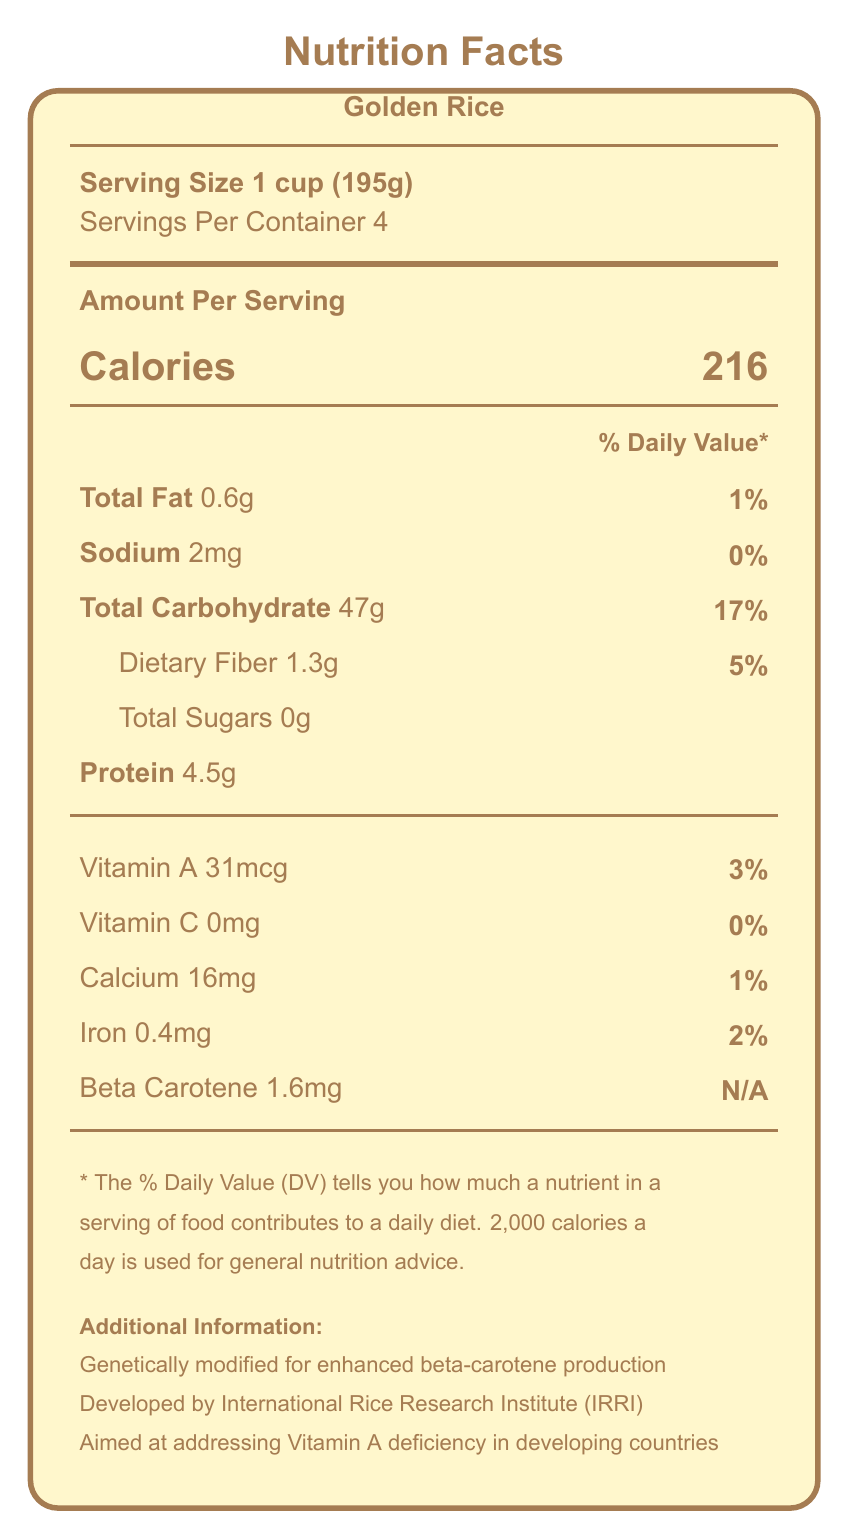what is the serving size of Golden Rice? The serving size is mentioned at the top of the Nutrition Facts section.
Answer: 1 cup (195g) how many servings are there per container? The servings per container information is listed directly below the serving size.
Answer: 4 how much Vitamin A does Golden Rice provide per serving? The amount of Vitamin A is listed in the middle section of the label with the other vitamins and minerals.
Answer: 31mcg what percentage of the daily value of calcium does Golden Rice contain? The percentage of the daily value for calcium is given on the right side next to the amount (16mg).
Answer: 1% how much protein is in one serving of Golden Rice? The protein content per serving is listed in the middle section of the Nutrition Facts.
Answer: 4.5g which countries are Golden Rice targeted for? A. Vietnam, Thailand, Malaysia B. Bangladesh, Philippines, Indonesia C. India, Pakistan, Sri Lanka D. China, Japan, South Korea The context information indicates the target countries are Bangladesh, the Philippines, and Indonesia.
Answer: B what is the total carbohydrate content in a serving of Golden Rice? The total carbohydrate content per serving is listed near the middle of the label.
Answer: 47g is Golden Rice suitable for tropical regions? The food security implications section notes that Golden Rice is suitable for tropical and subtropical regions.
Answer: Yes does Golden Rice have any additional pest resistance genes? The food security implications section specifies that Golden Rice has no additional resistance genes.
Answer: No which organization developed Golden Rice? The additional information section mentions that Golden Rice was developed by the International Rice Research Institute (IRRI).
Answer: International Rice Research Institute (IRRI) what is the genetic modification made to Golden Rice? A. Increased pest resistance B. Enhanced drought tolerance C. Enhanced beta-carotene production D. Increased yield The label states that Golden Rice has been genetically modified to enhance beta-carotene production.
Answer: C what are the potential economic benefits of Golden Rice? The economic considerations section provides detailed information on the economic sustainability and market aspects of Golden Rice.
Answer: The potential economic benefits include similar production costs to conventional rice, affordability for low-income consumers, and limited export potential due to GMO regulations in some countries. what is the intended purpose of Golden Rice? The additional information section mentions that Golden Rice is aimed at addressing Vitamin A deficiency in developing countries.
Answer: To address Vitamin A deficiency in developing countries. is Golden Rice approved for cultivation in the Philippines? The regulatory approval section notes that Golden Rice was approved for cultivation in the Philippines in 2019.
Answer: Yes what is the potential biodiversity impact of cultivating Golden Rice? The environmental impact section specifies that cultivating Golden Rice has no significant impact on wild rice varieties.
Answer: No significant impact on wild rice varieties summarize the Nutrition Facts Label for Golden Rice. A more detailed description includes specific contents like serving size, servings per container, percentage daily values, and context information regarding its agricultural and economic implications.
Answer: The Nutrition Facts Label for Golden Rice provides comprehensive information about its nutritional content, including calories, macronutrients, vitamins, and minerals per serving. Additionally, it includes data about its genetic modification for enhanced beta-carotene production, targeting of specific developing countries, economic considerations, and potential regulatory approvals. what is the export potential of Golden Rice to European Union countries? The document mentions limited export potential due to GMO regulations in some countries but does not specifically address the European Union.
Answer: Not enough information 